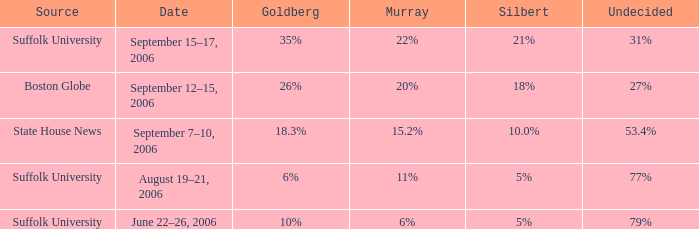What is the date of the poll where Murray had 11% from the Suffolk University source? August 19–21, 2006. 